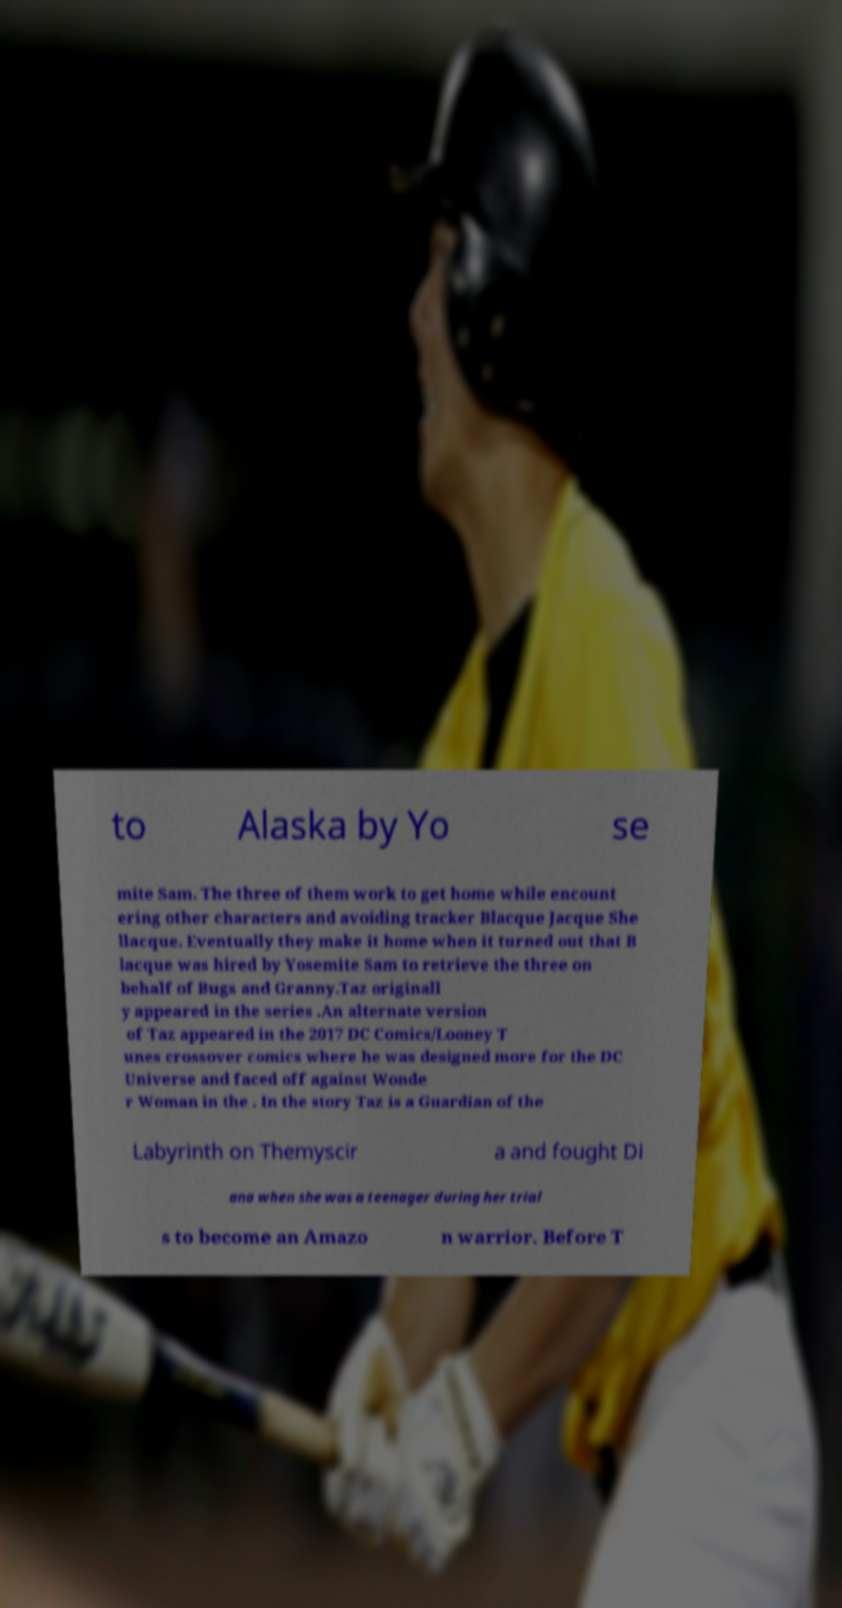Can you read and provide the text displayed in the image?This photo seems to have some interesting text. Can you extract and type it out for me? to Alaska by Yo se mite Sam. The three of them work to get home while encount ering other characters and avoiding tracker Blacque Jacque She llacque. Eventually they make it home when it turned out that B lacque was hired by Yosemite Sam to retrieve the three on behalf of Bugs and Granny.Taz originall y appeared in the series .An alternate version of Taz appeared in the 2017 DC Comics/Looney T unes crossover comics where he was designed more for the DC Universe and faced off against Wonde r Woman in the . In the story Taz is a Guardian of the Labyrinth on Themyscir a and fought Di ana when she was a teenager during her trial s to become an Amazo n warrior. Before T 